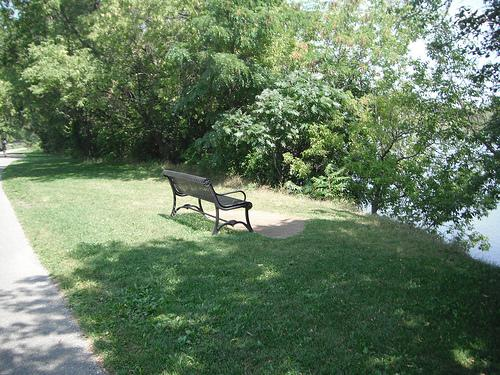Question: what is in the center of the picture?
Choices:
A. My parents.
B. A bench.
C. Air space.
D. It's a bit smudged.
Answer with the letter. Answer: B Question: what is on the left side of the picture?
Choices:
A. A piece of the picture that got cut out.
B. A sidewalk.
C. A stranger.
D. Animals.
Answer with the letter. Answer: B Question: how many people are sitting on the bench?
Choices:
A. Two.
B. Zero.
C. Three.
D. Ten.
Answer with the letter. Answer: B Question: what is the bench facing?
Choices:
A. The park.
B. Vending machine.
C. You.
D. Trees.
Answer with the letter. Answer: D 